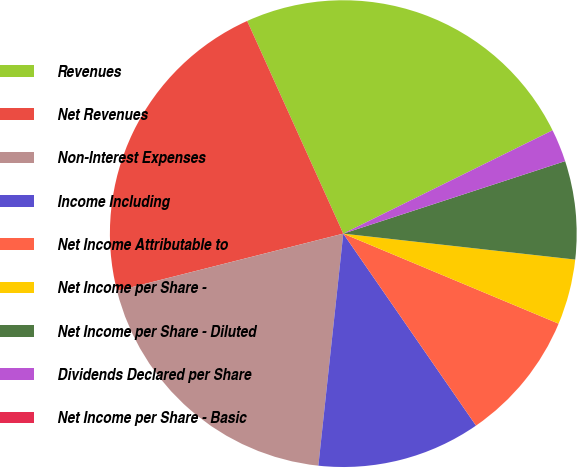Convert chart. <chart><loc_0><loc_0><loc_500><loc_500><pie_chart><fcel>Revenues<fcel>Net Revenues<fcel>Non-Interest Expenses<fcel>Income Including<fcel>Net Income Attributable to<fcel>Net Income per Share -<fcel>Net Income per Share - Diluted<fcel>Dividends Declared per Share<fcel>Net Income per Share - Basic<nl><fcel>24.46%<fcel>22.19%<fcel>19.35%<fcel>11.33%<fcel>9.07%<fcel>4.53%<fcel>6.8%<fcel>2.27%<fcel>0.0%<nl></chart> 